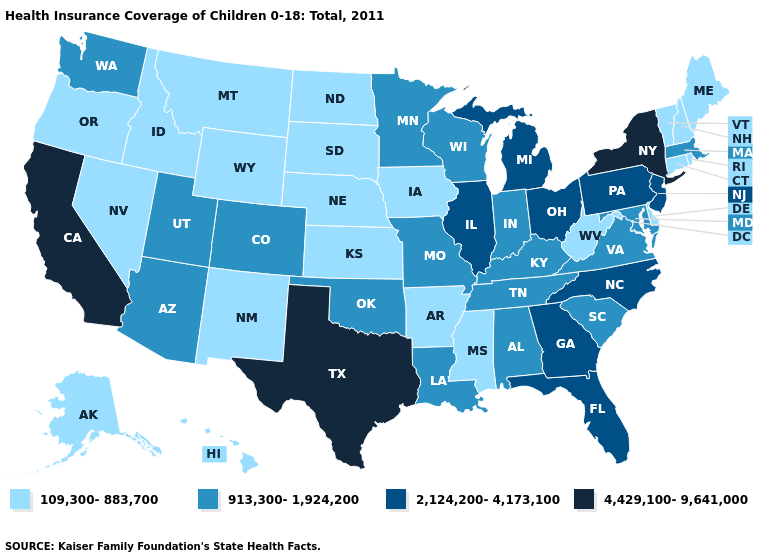What is the value of Maine?
Concise answer only. 109,300-883,700. How many symbols are there in the legend?
Write a very short answer. 4. What is the value of Louisiana?
Be succinct. 913,300-1,924,200. Does South Dakota have the lowest value in the MidWest?
Concise answer only. Yes. Does Idaho have a lower value than Kansas?
Concise answer only. No. Does Pennsylvania have a lower value than West Virginia?
Keep it brief. No. What is the highest value in the USA?
Quick response, please. 4,429,100-9,641,000. Name the states that have a value in the range 913,300-1,924,200?
Give a very brief answer. Alabama, Arizona, Colorado, Indiana, Kentucky, Louisiana, Maryland, Massachusetts, Minnesota, Missouri, Oklahoma, South Carolina, Tennessee, Utah, Virginia, Washington, Wisconsin. Which states have the lowest value in the South?
Short answer required. Arkansas, Delaware, Mississippi, West Virginia. Name the states that have a value in the range 109,300-883,700?
Keep it brief. Alaska, Arkansas, Connecticut, Delaware, Hawaii, Idaho, Iowa, Kansas, Maine, Mississippi, Montana, Nebraska, Nevada, New Hampshire, New Mexico, North Dakota, Oregon, Rhode Island, South Dakota, Vermont, West Virginia, Wyoming. What is the lowest value in states that border Missouri?
Short answer required. 109,300-883,700. Name the states that have a value in the range 4,429,100-9,641,000?
Quick response, please. California, New York, Texas. Name the states that have a value in the range 109,300-883,700?
Concise answer only. Alaska, Arkansas, Connecticut, Delaware, Hawaii, Idaho, Iowa, Kansas, Maine, Mississippi, Montana, Nebraska, Nevada, New Hampshire, New Mexico, North Dakota, Oregon, Rhode Island, South Dakota, Vermont, West Virginia, Wyoming. What is the value of Washington?
Answer briefly. 913,300-1,924,200. 